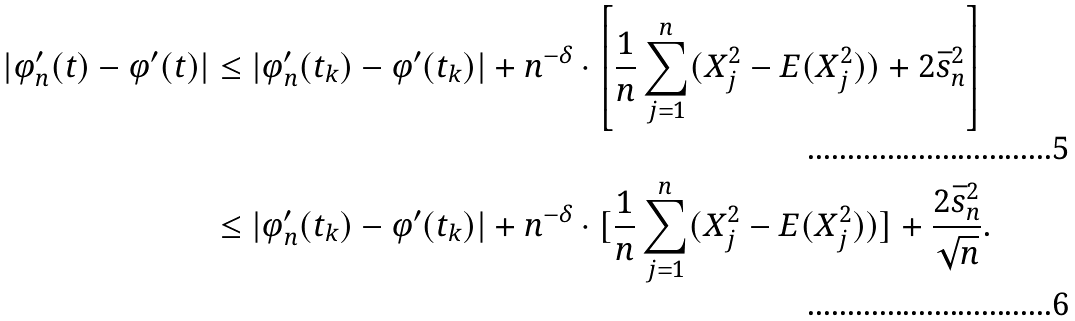Convert formula to latex. <formula><loc_0><loc_0><loc_500><loc_500>| \varphi _ { n } ^ { \prime } ( t ) - \varphi ^ { \prime } ( t ) | & \leq | \varphi _ { n } ^ { \prime } ( t _ { k } ) - \varphi ^ { \prime } ( t _ { k } ) | + n ^ { - \delta } \cdot \left [ \frac { 1 } { n } \sum _ { j = 1 } ^ { n } ( X _ { j } ^ { 2 } - E ( X _ { j } ^ { 2 } ) ) + 2 \bar { s } _ { n } ^ { 2 } \right ] \\ & \leq | \varphi _ { n } ^ { \prime } ( t _ { k } ) - \varphi ^ { \prime } ( t _ { k } ) | + n ^ { - \delta } \cdot [ \frac { 1 } { n } \sum _ { j = 1 } ^ { n } ( X _ { j } ^ { 2 } - E ( X _ { j } ^ { 2 } ) ) ] + \frac { 2 \bar { s } _ { n } ^ { 2 } } { \sqrt { n } } .</formula> 